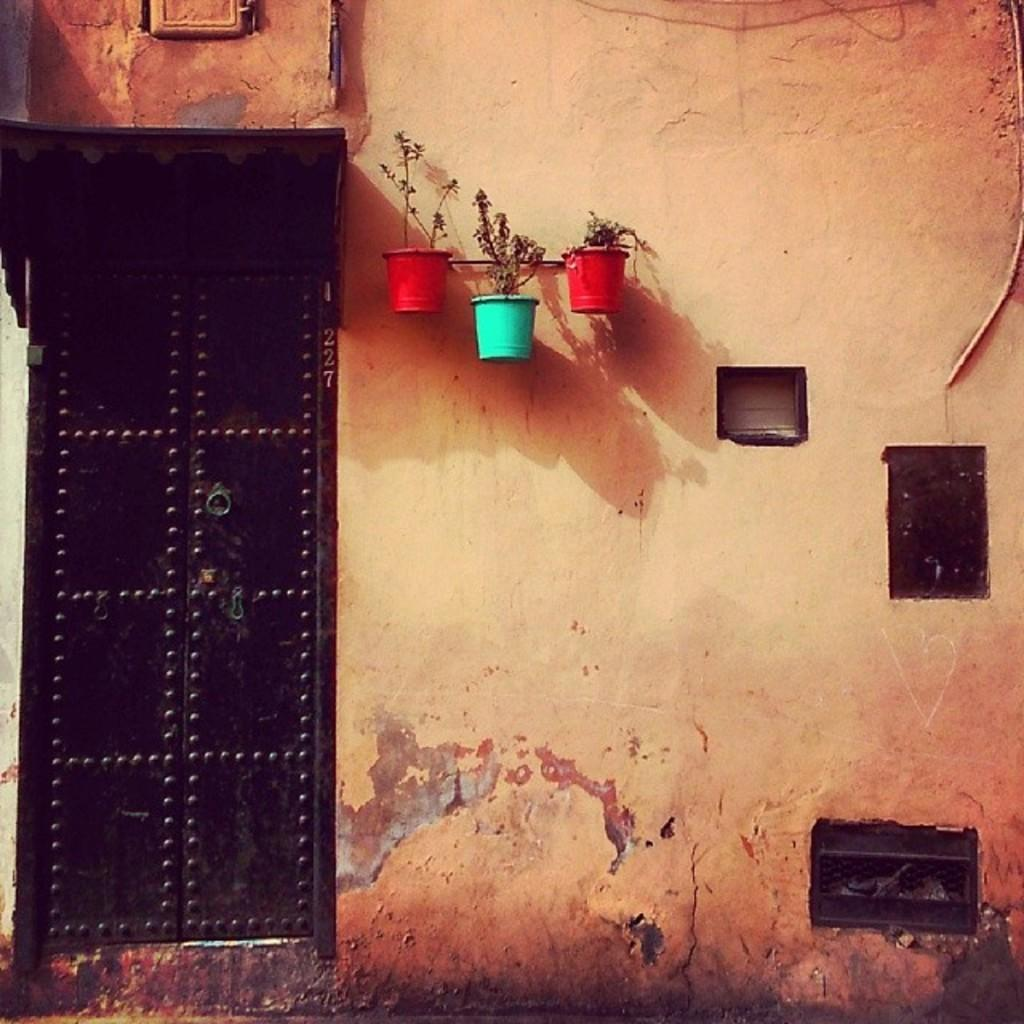What is the main structure visible in the image? There is a wall in the image. Where is the door located on the wall? The door is on the left side of the wall. What can be seen in the middle of the image? There are three plants in the middle of the image. How many prisoners are visible in the image? There is no indication of a prison or prisoners in the image; it only features a wall, a door, and three plants. What type of nose can be seen on the plants in the image? Plants do not have noses, so this question is not applicable to the image. 